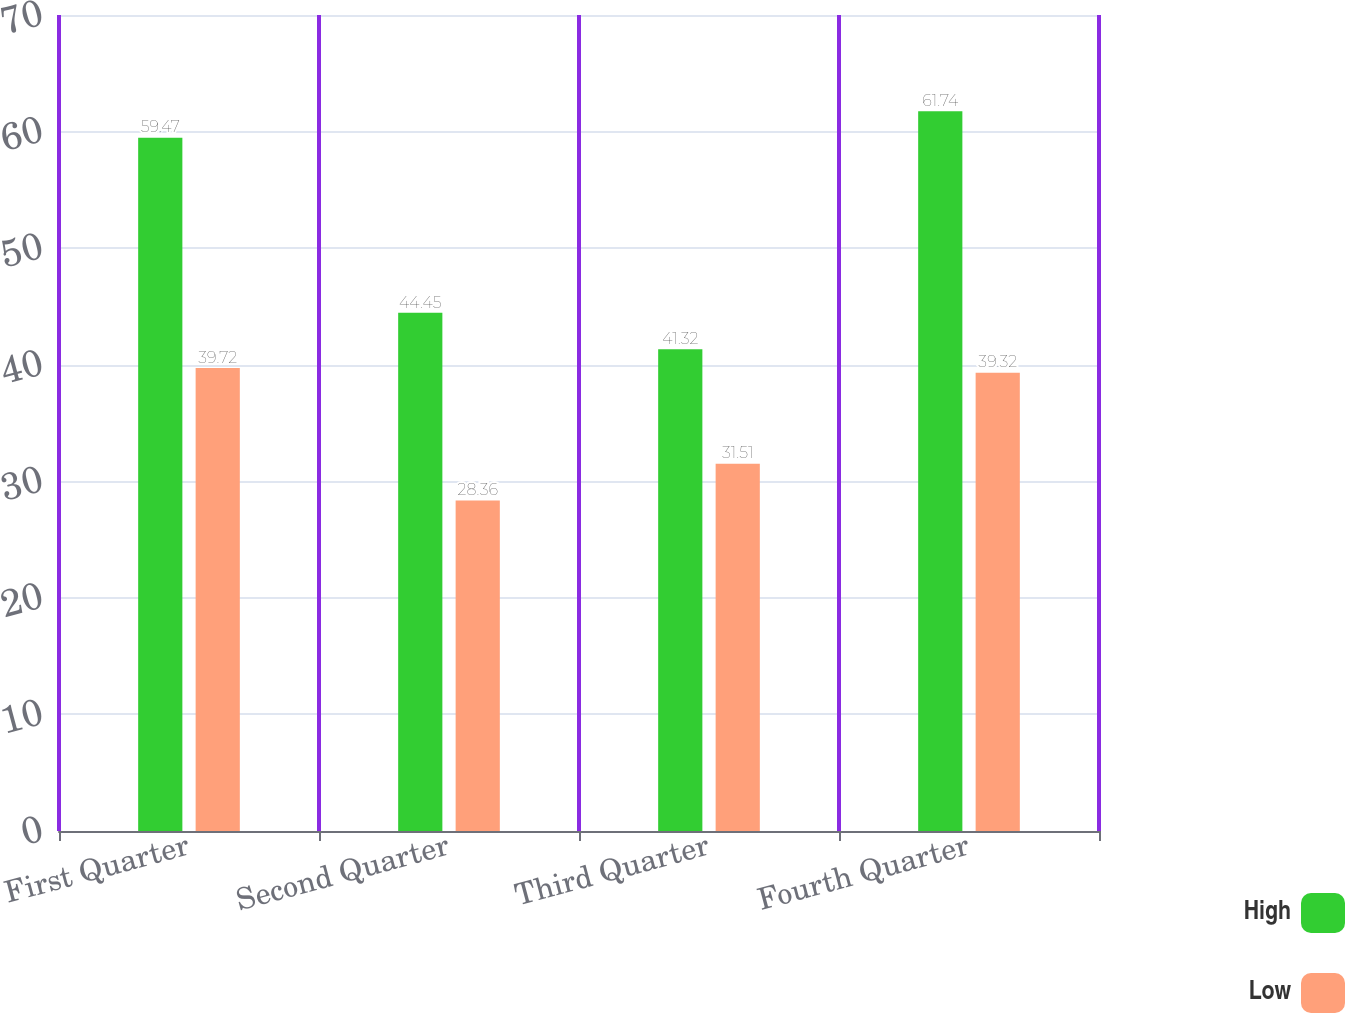Convert chart to OTSL. <chart><loc_0><loc_0><loc_500><loc_500><stacked_bar_chart><ecel><fcel>First Quarter<fcel>Second Quarter<fcel>Third Quarter<fcel>Fourth Quarter<nl><fcel>High<fcel>59.47<fcel>44.45<fcel>41.32<fcel>61.74<nl><fcel>Low<fcel>39.72<fcel>28.36<fcel>31.51<fcel>39.32<nl></chart> 